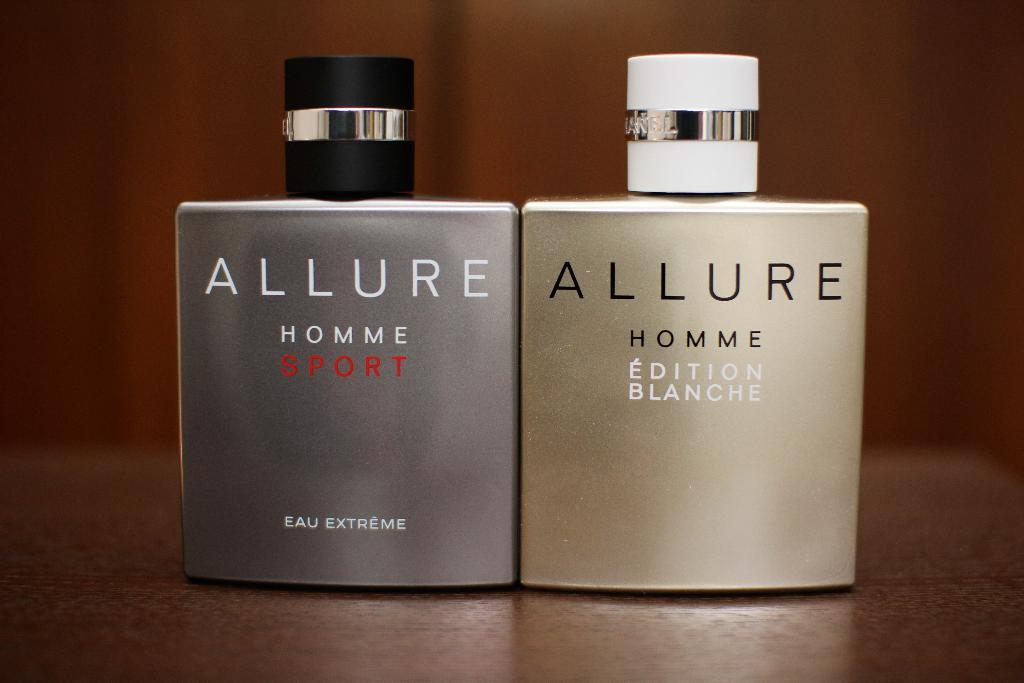<image>
Summarize the visual content of the image. Two bottles of Allure brand cologne sit on a table. 